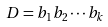Convert formula to latex. <formula><loc_0><loc_0><loc_500><loc_500>D = b _ { 1 } b _ { 2 } \cdots b _ { k }</formula> 